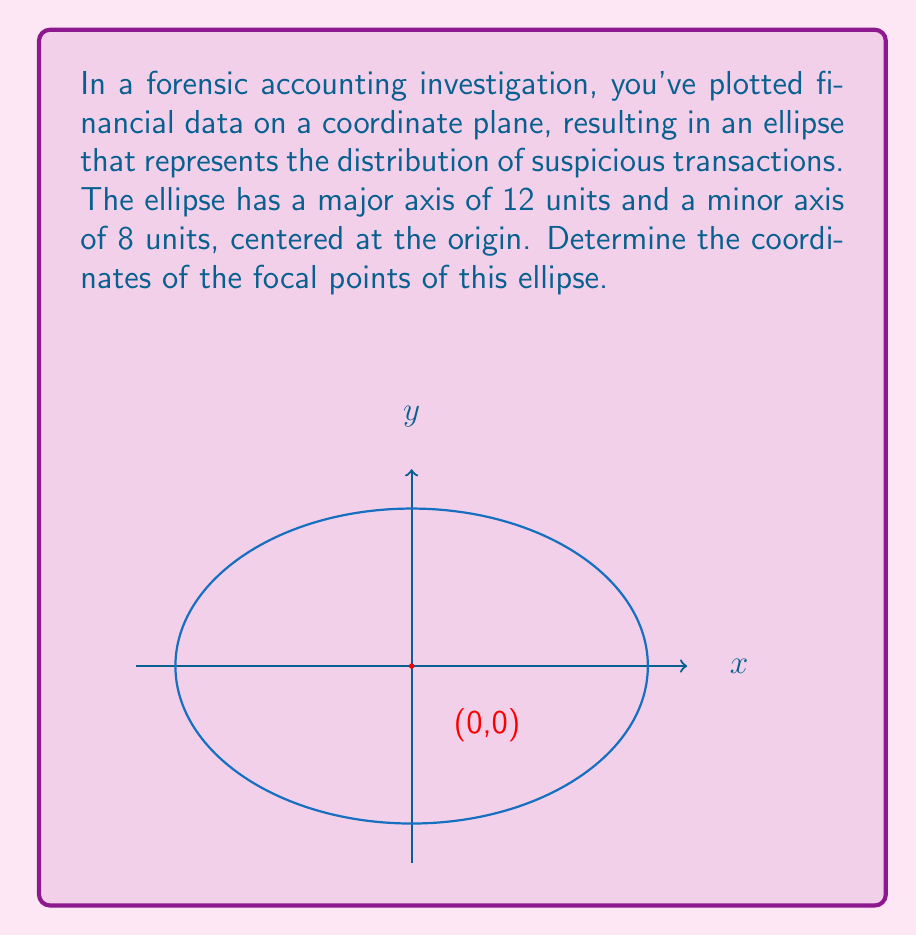Solve this math problem. To find the focal points of an ellipse, we need to follow these steps:

1) First, recall the equation for the distance between the center and a focal point (c):

   $$c^2 = a^2 - b^2$$

   where $a$ is half the length of the major axis and $b$ is half the length of the minor axis.

2) In this case:
   $a = 6$ (half of 12)
   $b = 4$ (half of 8)

3) Substitute these values into the equation:

   $$c^2 = 6^2 - 4^2 = 36 - 16 = 20$$

4) Take the square root of both sides:

   $$c = \sqrt{20} = 2\sqrt{5}$$

5) The focal points are located on the major axis, which in this case is the x-axis since the ellipse is centered at the origin. The distance from the center to each focal point is $c$.

6) Therefore, the coordinates of the focal points are:

   $(\pm 2\sqrt{5}, 0)$

This means there are two focal points: one at $(2\sqrt{5}, 0)$ and another at $(-2\sqrt{5}, 0)$.
Answer: $(\pm 2\sqrt{5}, 0)$ 